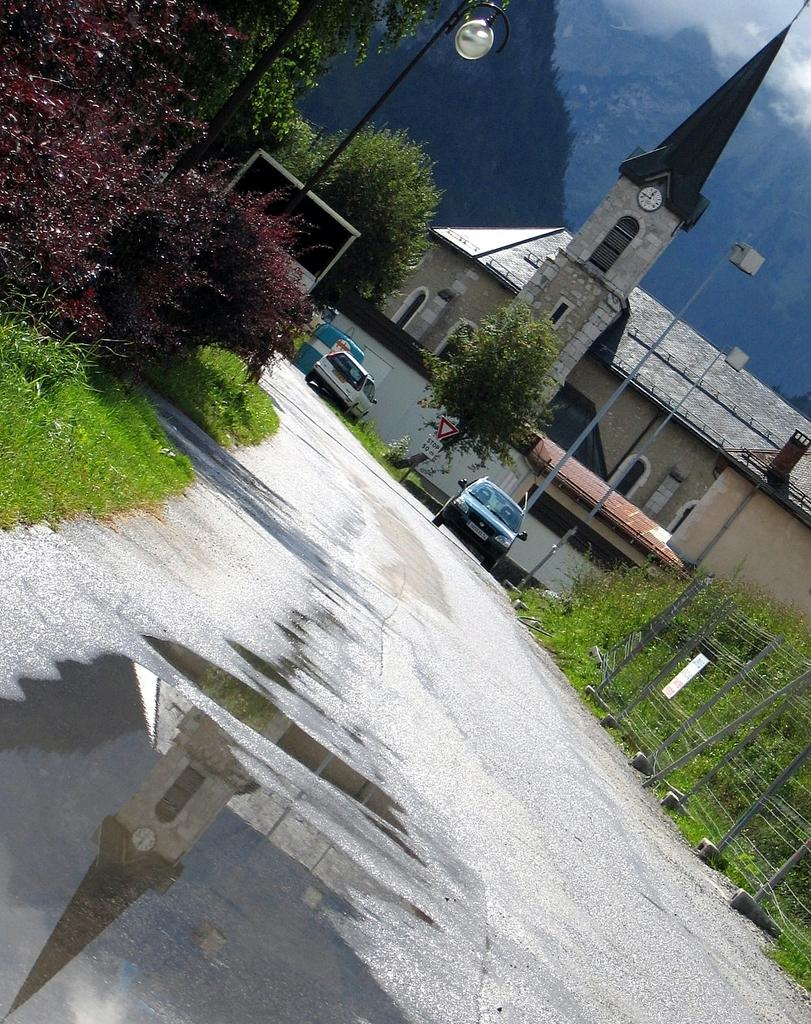What is covering the road in the image? There is water on the road in the image. What are the parked vehicles in the image? Cars are parked on the road in the image. What type of barrier can be seen in the image? There is a fence in the image. What type of vegetation is present in the image? Shrubs are present in the image. What type of structure can be seen in the image? Boards are visible in the image. What type of lighting infrastructure is in the image? Light poles are in the image. What type of building is in the image? There is a stone building in the image. What type of natural feature is visible in the background of the image? Hills are visible in the background of the image. What type of weather condition is present in the background of the image? Fog is present in the background of the image. How many letters are being delivered by the giants in the image? There are no giants or letters present in the image. Where is the hall located in the image? There is no hall present in the image. 